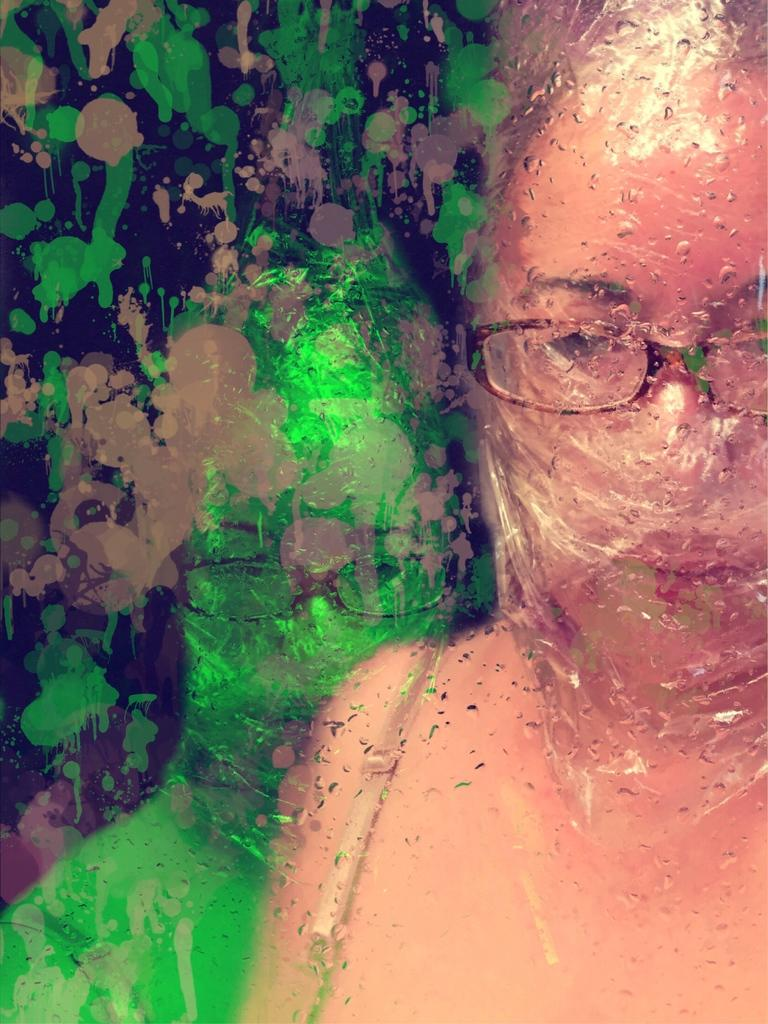Who is present in the image? There is a woman in the image. What is the woman wearing? The woman is wearing spectacles. What else can be seen in the image besides the woman? There is paint visible in the image. Can you describe any other features of the image? There is a reflection of the woman in the image. What is the title of the painting in the image? There is no information about a painting or its title in the image. How does the woman's nose appear in the reflection? The nose is not mentioned in the provided facts, and there is no indication of a reflection of the woman's nose in the image. 